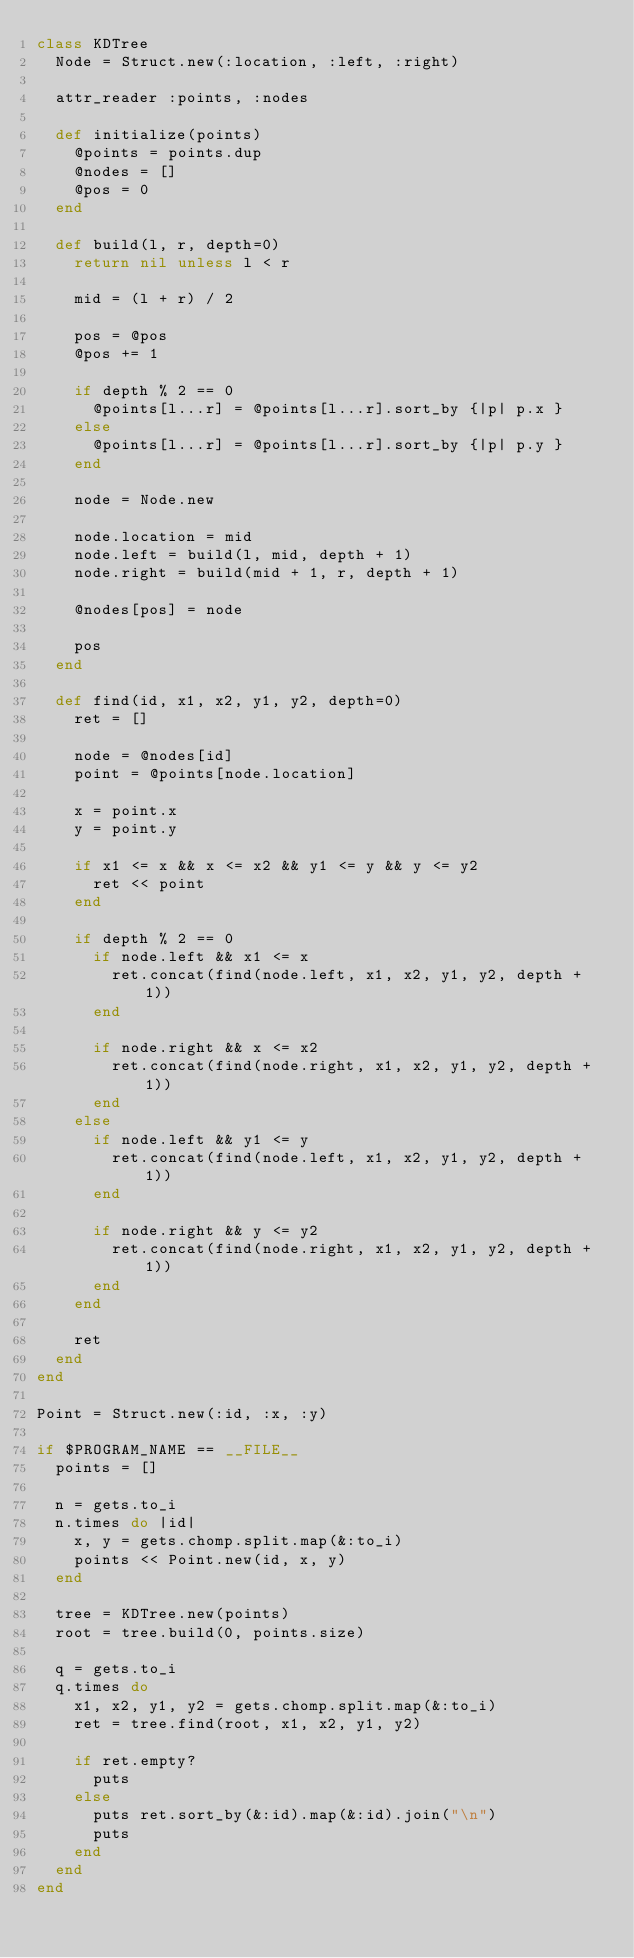<code> <loc_0><loc_0><loc_500><loc_500><_Ruby_>class KDTree
  Node = Struct.new(:location, :left, :right)

  attr_reader :points, :nodes

  def initialize(points)
    @points = points.dup
    @nodes = []
    @pos = 0
  end

  def build(l, r, depth=0)
    return nil unless l < r

    mid = (l + r) / 2

    pos = @pos
    @pos += 1

    if depth % 2 == 0
      @points[l...r] = @points[l...r].sort_by {|p| p.x }
    else
      @points[l...r] = @points[l...r].sort_by {|p| p.y }
    end

    node = Node.new

    node.location = mid
    node.left = build(l, mid, depth + 1)
    node.right = build(mid + 1, r, depth + 1)

    @nodes[pos] = node

    pos
  end

  def find(id, x1, x2, y1, y2, depth=0)
    ret = []

    node = @nodes[id]
    point = @points[node.location]

    x = point.x
    y = point.y

    if x1 <= x && x <= x2 && y1 <= y && y <= y2
      ret << point
    end

    if depth % 2 == 0
      if node.left && x1 <= x
        ret.concat(find(node.left, x1, x2, y1, y2, depth + 1))
      end

      if node.right && x <= x2
        ret.concat(find(node.right, x1, x2, y1, y2, depth + 1))
      end
    else
      if node.left && y1 <= y
        ret.concat(find(node.left, x1, x2, y1, y2, depth + 1))
      end

      if node.right && y <= y2
        ret.concat(find(node.right, x1, x2, y1, y2, depth + 1))
      end
    end

    ret
  end
end

Point = Struct.new(:id, :x, :y)

if $PROGRAM_NAME == __FILE__
  points = []

  n = gets.to_i
  n.times do |id|
    x, y = gets.chomp.split.map(&:to_i)
    points << Point.new(id, x, y)
  end

  tree = KDTree.new(points)
  root = tree.build(0, points.size)

  q = gets.to_i
  q.times do
    x1, x2, y1, y2 = gets.chomp.split.map(&:to_i)
    ret = tree.find(root, x1, x2, y1, y2)

    if ret.empty?
      puts
    else
      puts ret.sort_by(&:id).map(&:id).join("\n")
      puts
    end
  end
end</code> 